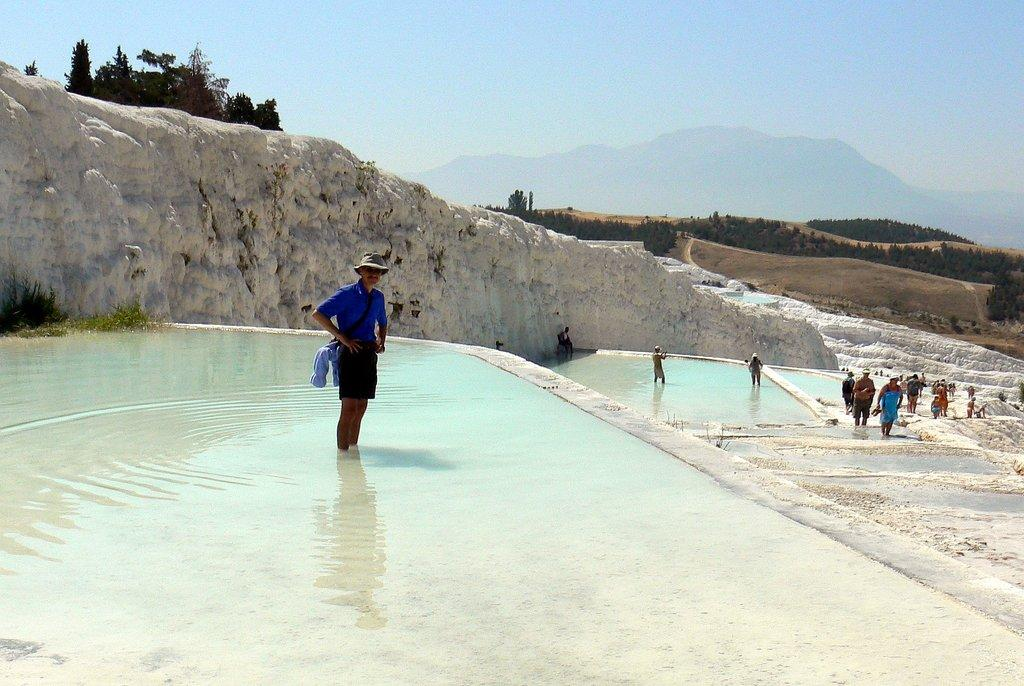What are the people in the image doing? There are people standing in water and a group of people standing on the ground in the image. What can be seen in the background of the image? Plants, hills, a group of trees, and the sky are visible in the image. What type of dust can be seen covering the system in the image? There is no dust or system present in the image. What is inside the box that is visible in the image? There is no box present in the image. 